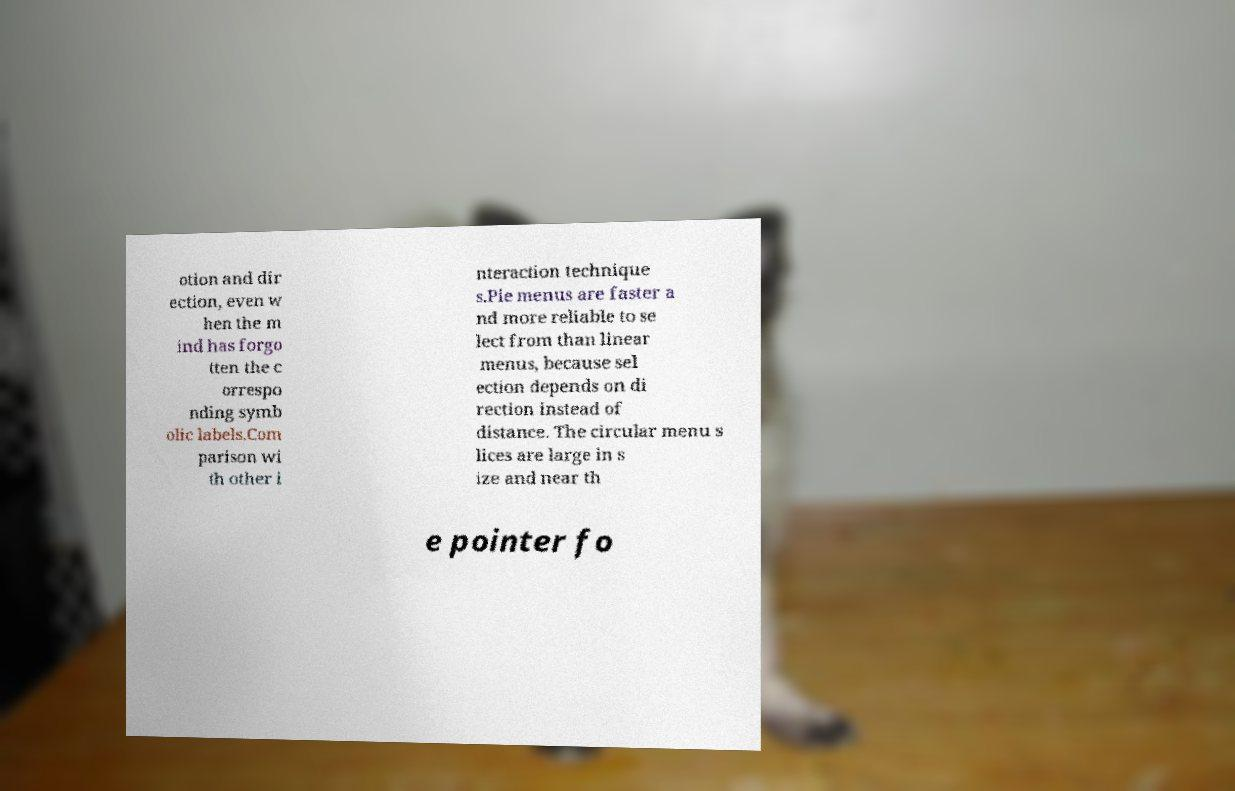What messages or text are displayed in this image? I need them in a readable, typed format. otion and dir ection, even w hen the m ind has forgo tten the c orrespo nding symb olic labels.Com parison wi th other i nteraction technique s.Pie menus are faster a nd more reliable to se lect from than linear menus, because sel ection depends on di rection instead of distance. The circular menu s lices are large in s ize and near th e pointer fo 